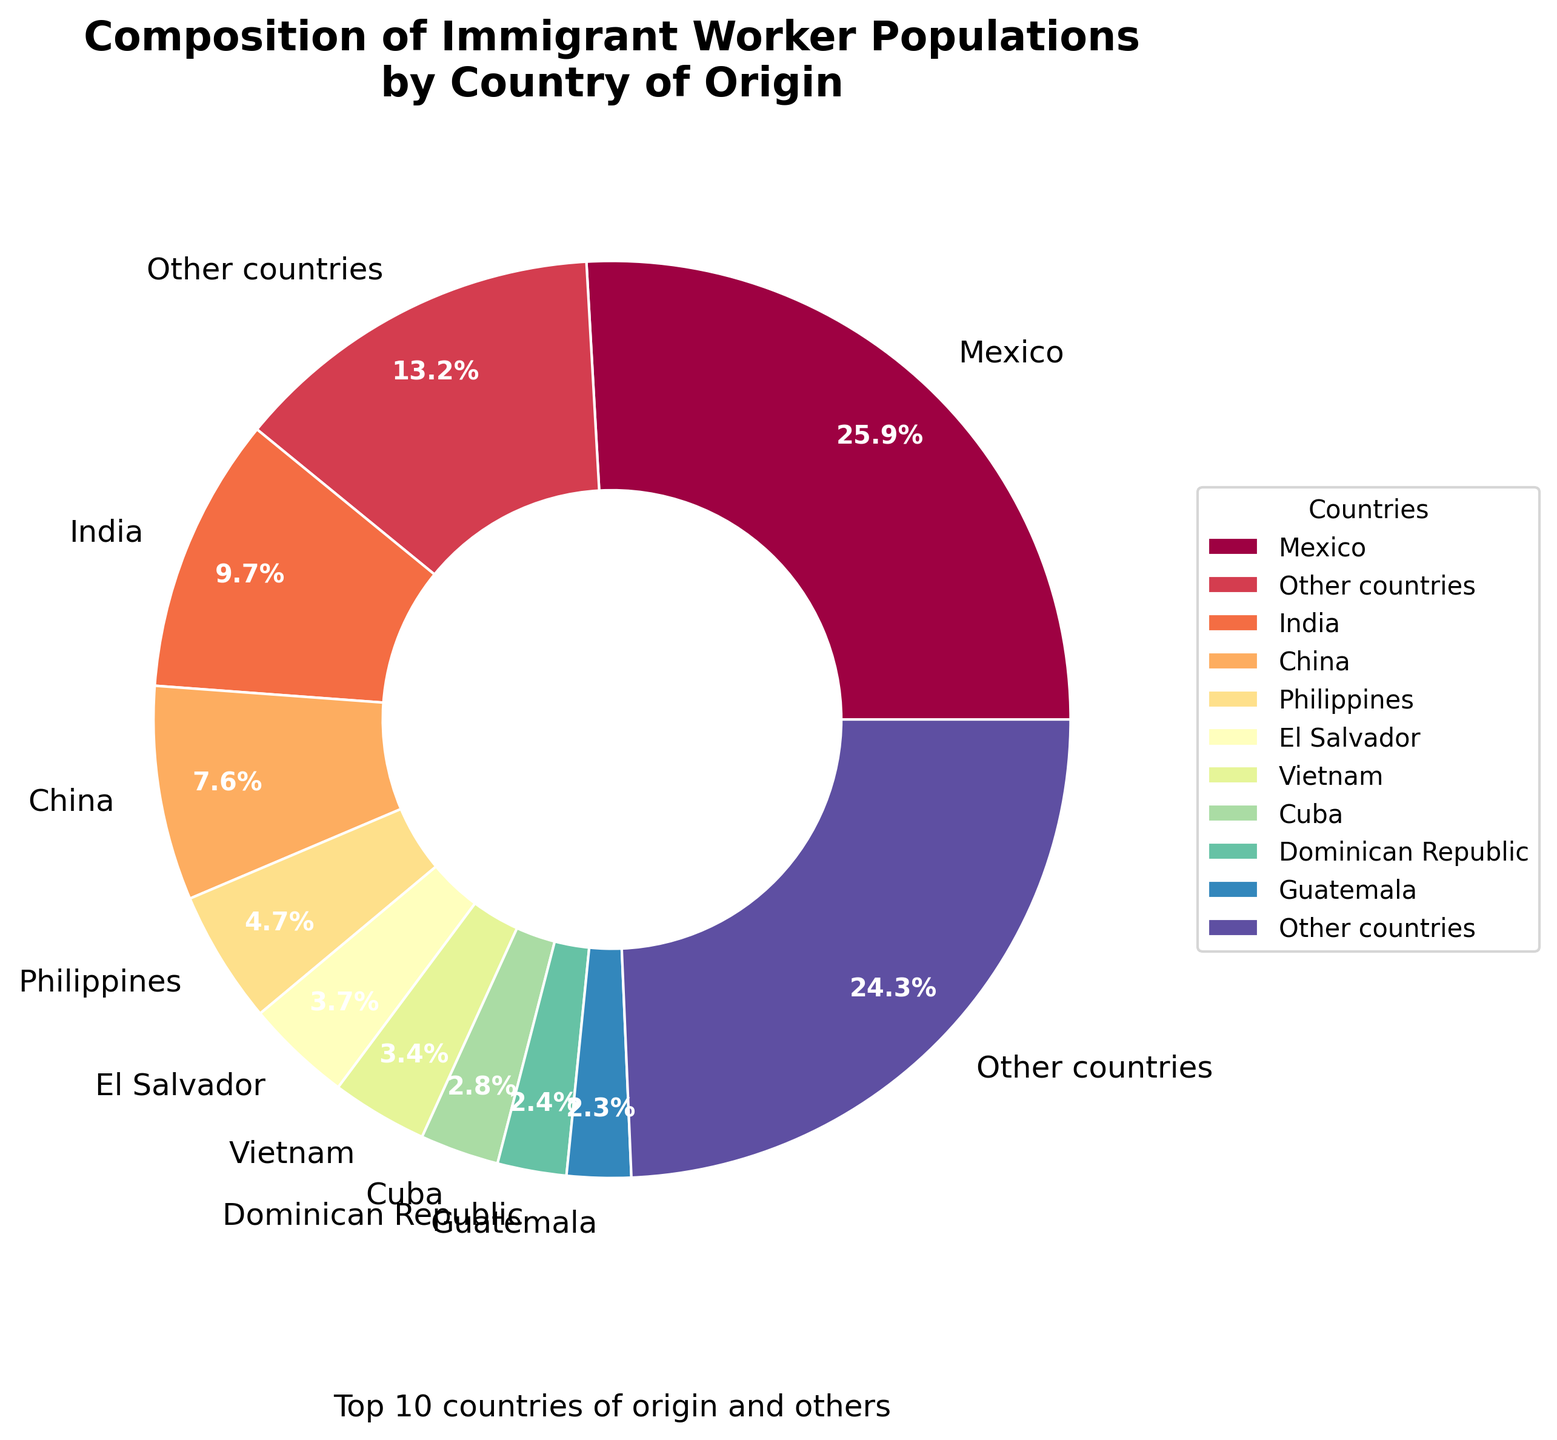What percentage of immigrant workers come from Central American countries in the top 10? The Central American countries in the top 10 are El Salvador, Guatemala, and Honduras. Summing their percentages gives: 4.3 + 2.6 + 1.5 = 8.4%
Answer: 8.4% Which country of origin has the second largest percentage of immigrant workers? By looking at the pie chart, the country with the second largest segment after Mexico is India.
Answer: India What is the combined percentage of immigrant workers from China and the Philippines? According to the pie chart, the percentage for China is 8.7% and for the Philippines is 5.4%. Adding these together: 8.7 + 5.4 = 14.1%
Answer: 14.1% How does the percentage of immigrant workers from Nigeria compare to South Korea? The pie chart shows Nigeria at 1.2% and South Korea at 1.3%. Therefore, Nigeria's percentage is slightly lower than South Korea's.
Answer: Nigeria's percentage is lower What's the difference between the highest and the lowest percentages in the top 10 countries? The highest percentage is for Mexico (29.8%) and the lowest in the top 10 is for Jamaica (2.1%). Their difference is 29.8 - 2.1 = 27.7%.
Answer: 27.7% Which country outside of the top 10 has the highest proportion of immigrant workers? From the slice labeled "Other countries" it's clear that this category collectively represents 15.2% but doesn't specify individual contributions. However, based on the data provided, the highest percentages outside the top 10 are tied between Brazil and South Korea at 1.3%.
Answer: Brazil and South Korea (tied) What visual feature helps to identify the country with the highest percentage of immigrant workers? The country with the highest percentage, Mexico, can be visually identified by the largest slice on the pie chart. It's the most prominent segment.
Answer: Largest slice If you sum up the percentages of all the countries in the top four, what is the total? The top four countries are Mexico (29.8%), India (11.2%), China (8.7%), and the Philippines (5.4%). Summing these gives: 29.8 + 11.2 + 8.7 + 5.4 = 55.1%.
Answer: 55.1% 